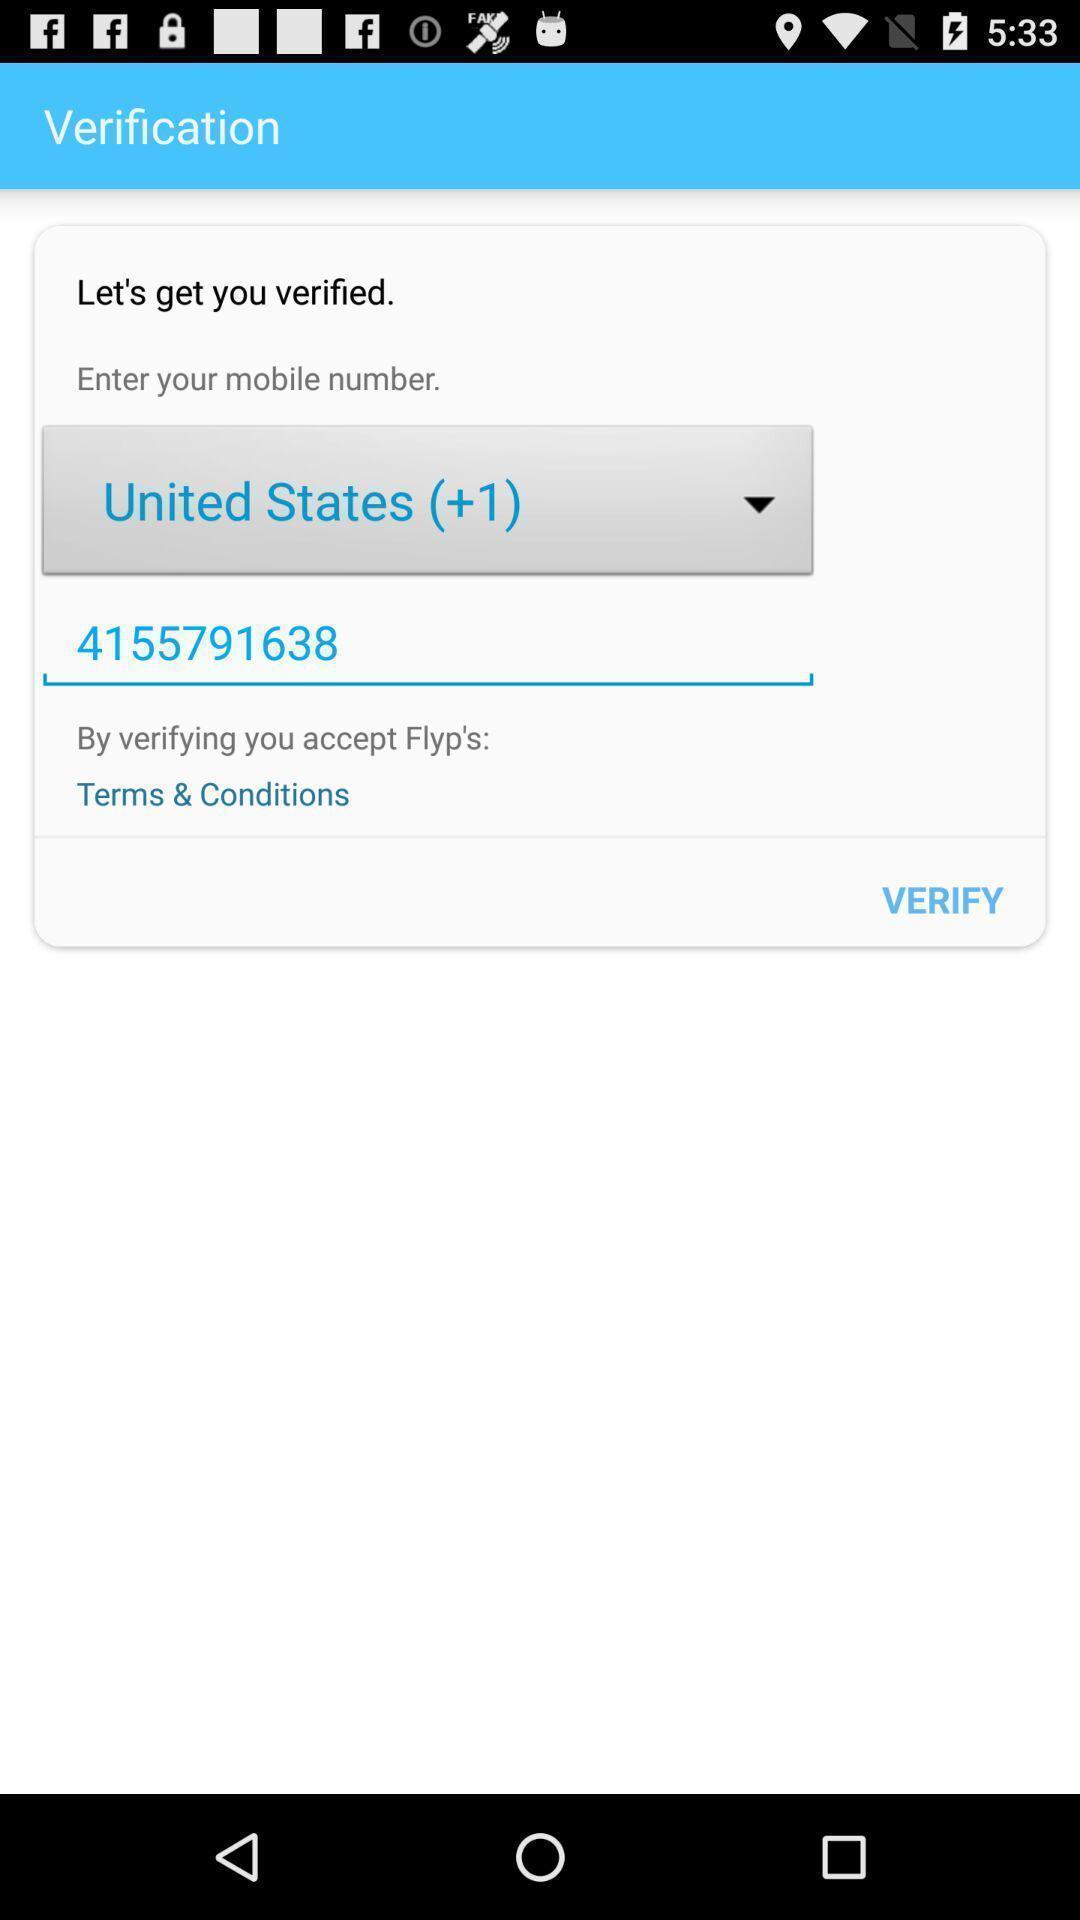Describe the key features of this screenshot. Verifying page. 